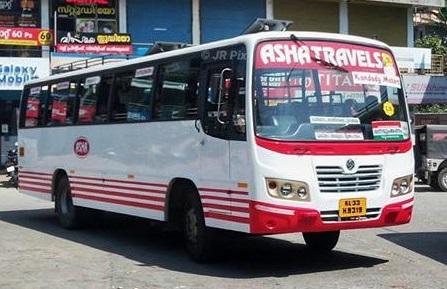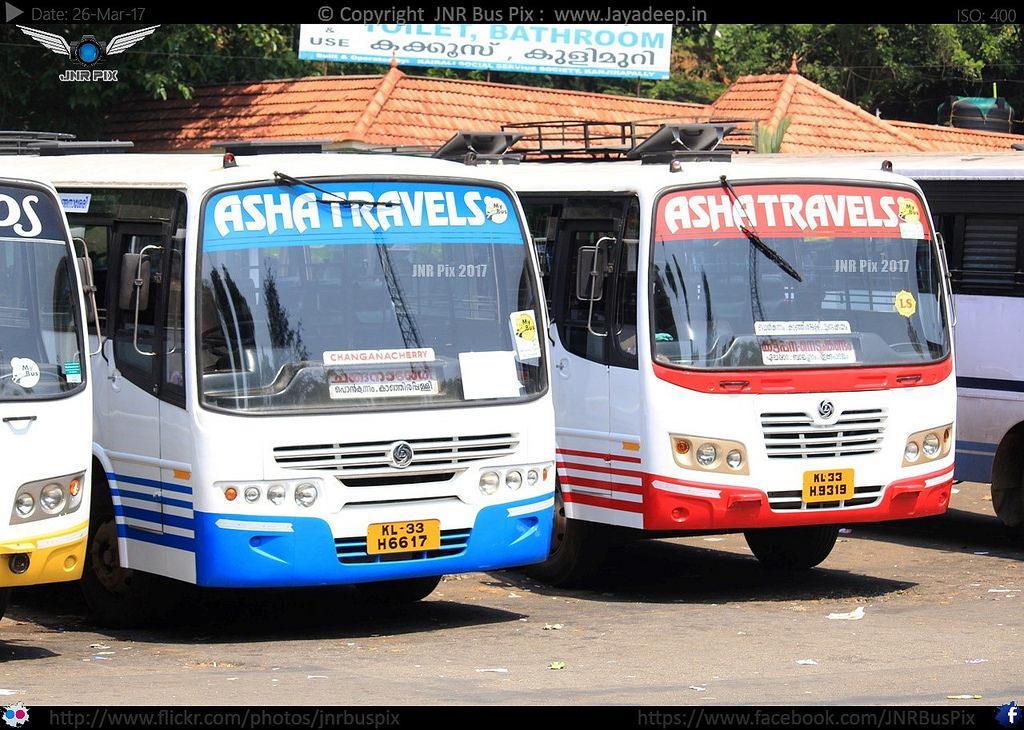The first image is the image on the left, the second image is the image on the right. For the images shown, is this caption "The left and right image contains the same number of travel buses." true? Answer yes or no. No. The first image is the image on the left, the second image is the image on the right. Analyze the images presented: Is the assertion "The left image shows one primarily white bus with a flat, slightly sloped front displayed at an angle facing rightward." valid? Answer yes or no. Yes. 